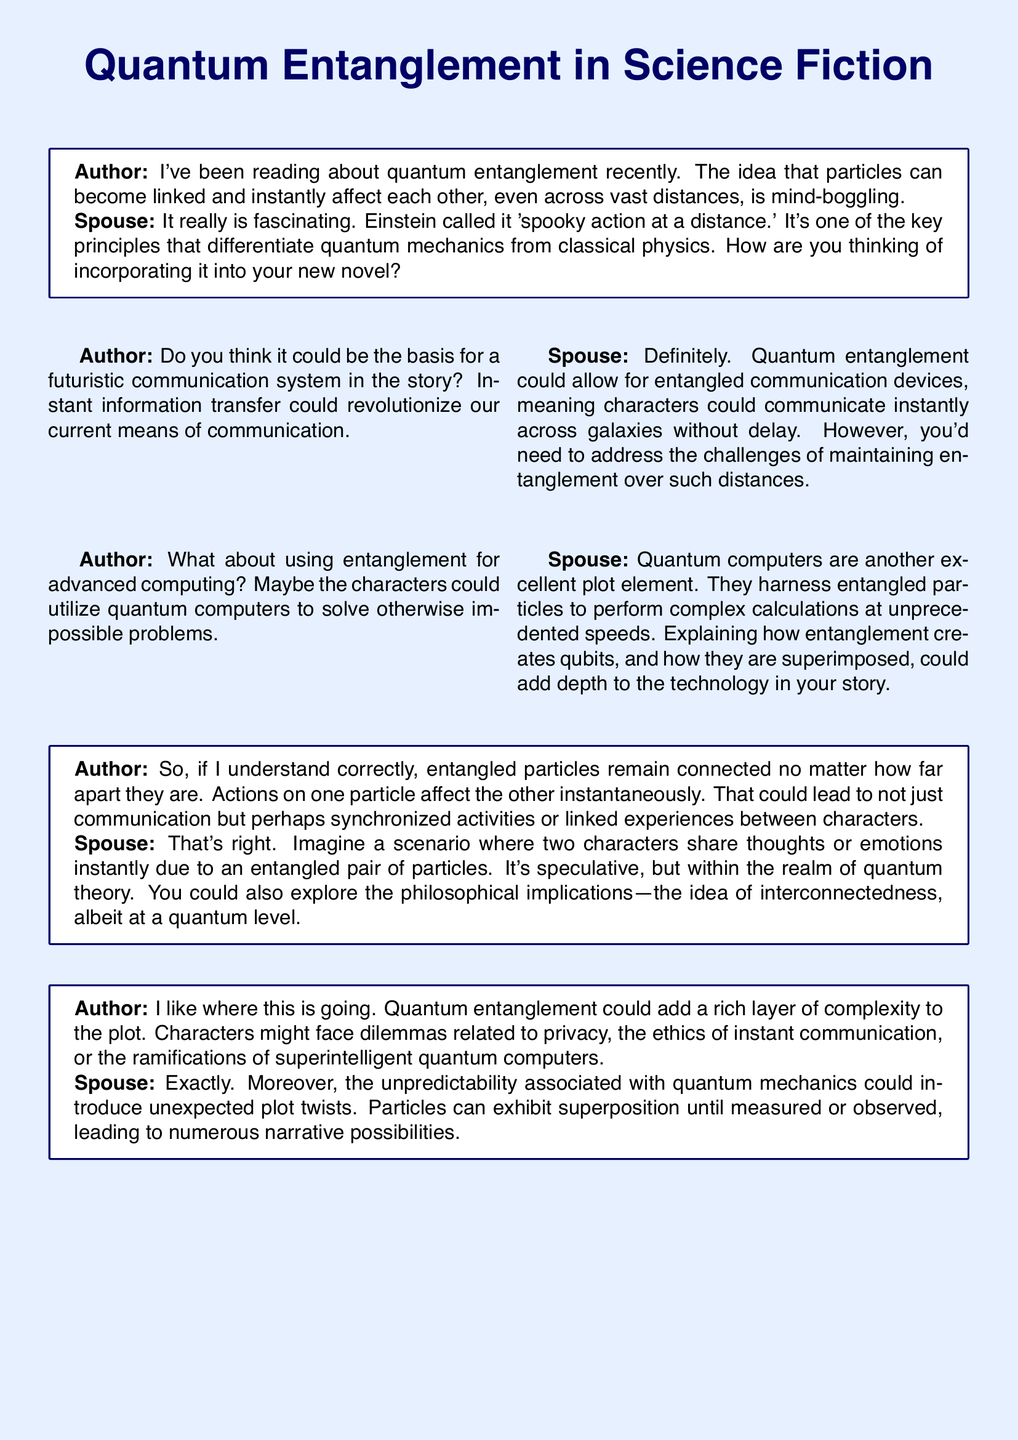What is the main topic discussed in the transcript? The transcript discusses quantum entanglement and its implications for plot development in a novel.
Answer: Quantum entanglement Who called it 'spooky action at a distance'? The spouse mentions Einstein's term for quantum entanglement.
Answer: Einstein What could quantum entanglement allow for in the story? The author suggests it could be the basis for a futuristic communication system.
Answer: Futuristic communication system What advanced technology is mentioned that could utilize entangled particles? The spouse refers to quantum computers that could solve complex calculations.
Answer: Quantum computers What philosophical idea could be explored through the characters? The spouse suggests exploring the idea of interconnectedness at a quantum level.
Answer: Interconnectedness What ethical dilemmas could arise from quantum entanglement? The author notes dilemmas related to privacy and the ethics of instant communication.
Answer: Privacy and ethics What unpredictable aspect of quantum mechanics could introduce plot twists? The spouse highlights that particles can exhibit superposition until observed.
Answer: Superposition What is one potential outcome of characters sharing thoughts or emotions? The spouse describes a scenario where characters are linked through entangled particles.
Answer: Linked experiences 